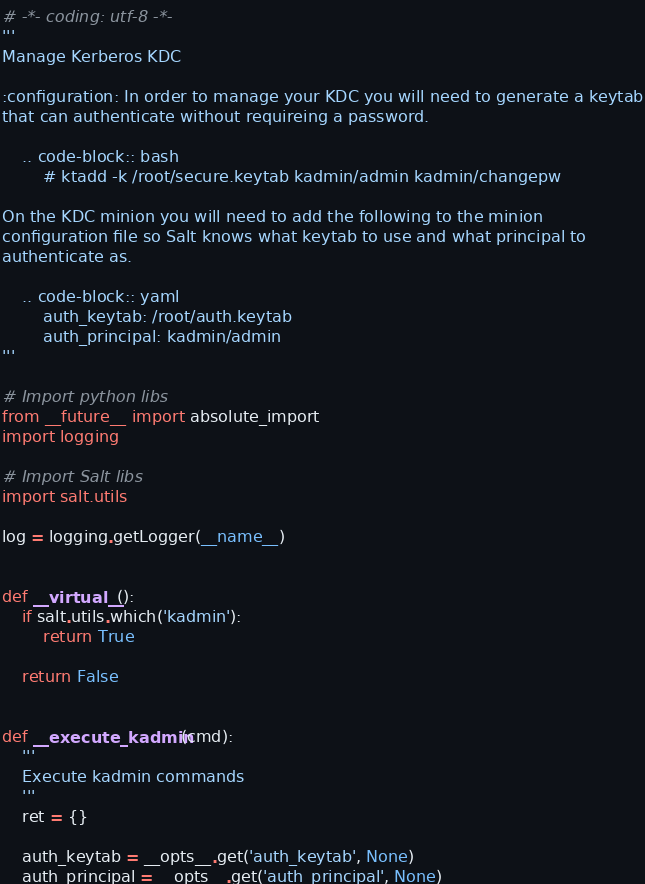<code> <loc_0><loc_0><loc_500><loc_500><_Python_># -*- coding: utf-8 -*-
'''
Manage Kerberos KDC

:configuration: In order to manage your KDC you will need to generate a keytab
that can authenticate without requireing a password.

    .. code-block:: bash
        # ktadd -k /root/secure.keytab kadmin/admin kadmin/changepw

On the KDC minion you will need to add the following to the minion
configuration file so Salt knows what keytab to use and what principal to
authenticate as.

    .. code-block:: yaml
        auth_keytab: /root/auth.keytab
        auth_principal: kadmin/admin
'''

# Import python libs
from __future__ import absolute_import
import logging

# Import Salt libs
import salt.utils

log = logging.getLogger(__name__)


def __virtual__():
    if salt.utils.which('kadmin'):
        return True

    return False


def __execute_kadmin(cmd):
    '''
    Execute kadmin commands
    '''
    ret = {}

    auth_keytab = __opts__.get('auth_keytab', None)
    auth_principal = __opts__.get('auth_principal', None)
</code> 